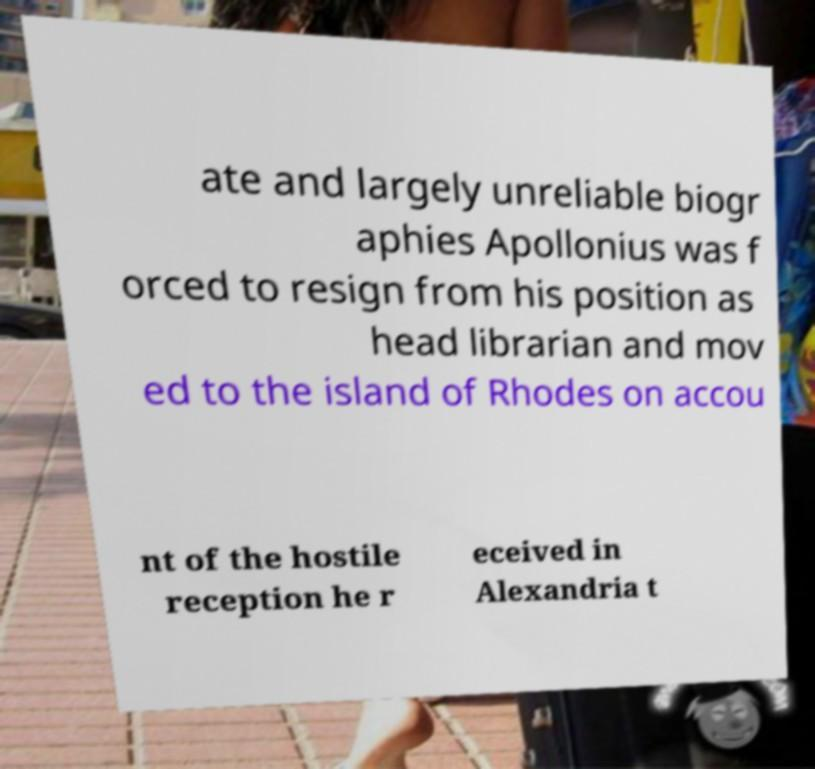Can you accurately transcribe the text from the provided image for me? ate and largely unreliable biogr aphies Apollonius was f orced to resign from his position as head librarian and mov ed to the island of Rhodes on accou nt of the hostile reception he r eceived in Alexandria t 